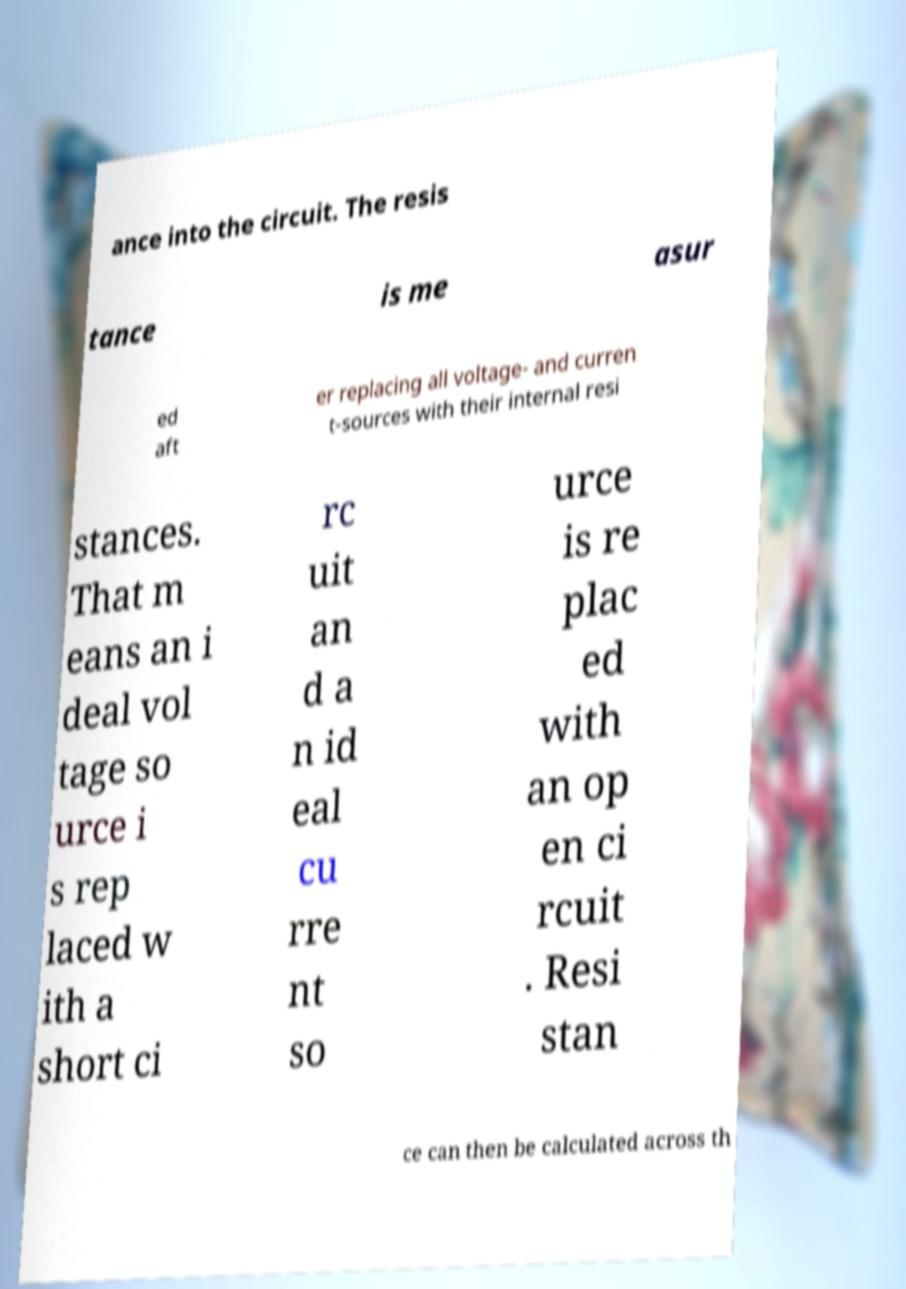Can you accurately transcribe the text from the provided image for me? ance into the circuit. The resis tance is me asur ed aft er replacing all voltage- and curren t-sources with their internal resi stances. That m eans an i deal vol tage so urce i s rep laced w ith a short ci rc uit an d a n id eal cu rre nt so urce is re plac ed with an op en ci rcuit . Resi stan ce can then be calculated across th 